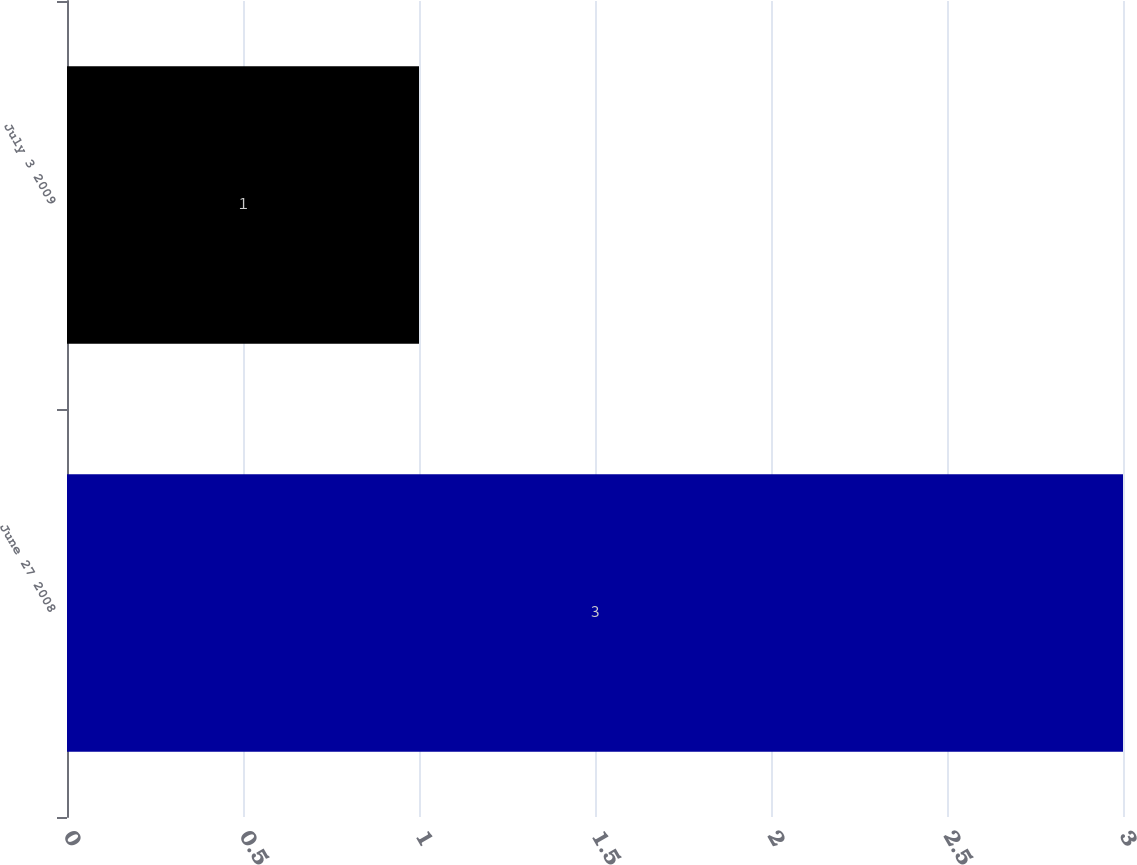<chart> <loc_0><loc_0><loc_500><loc_500><bar_chart><fcel>June 27 2008<fcel>July 3 2009<nl><fcel>3<fcel>1<nl></chart> 